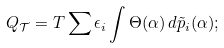<formula> <loc_0><loc_0><loc_500><loc_500>Q _ { \mathcal { T } } = T \sum \epsilon _ { i } \int \Theta ( \alpha ) \, d \tilde { p } _ { i } ( \alpha ) ;</formula> 